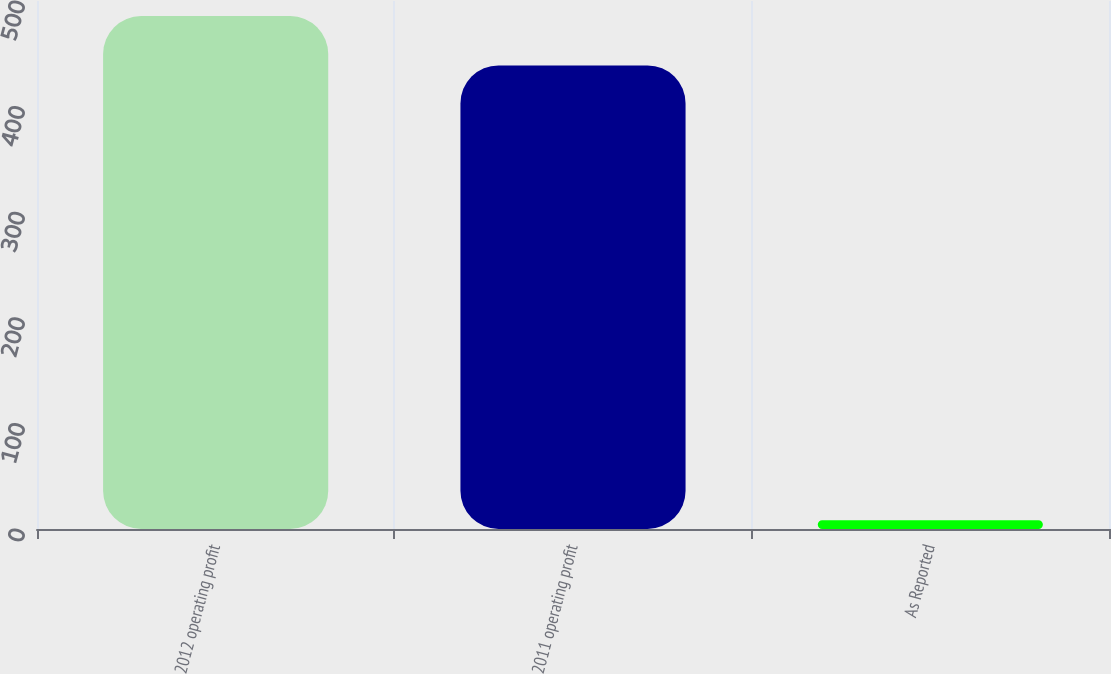Convert chart to OTSL. <chart><loc_0><loc_0><loc_500><loc_500><bar_chart><fcel>2012 operating profit<fcel>2011 operating profit<fcel>As Reported<nl><fcel>485.77<fcel>439<fcel>8.3<nl></chart> 